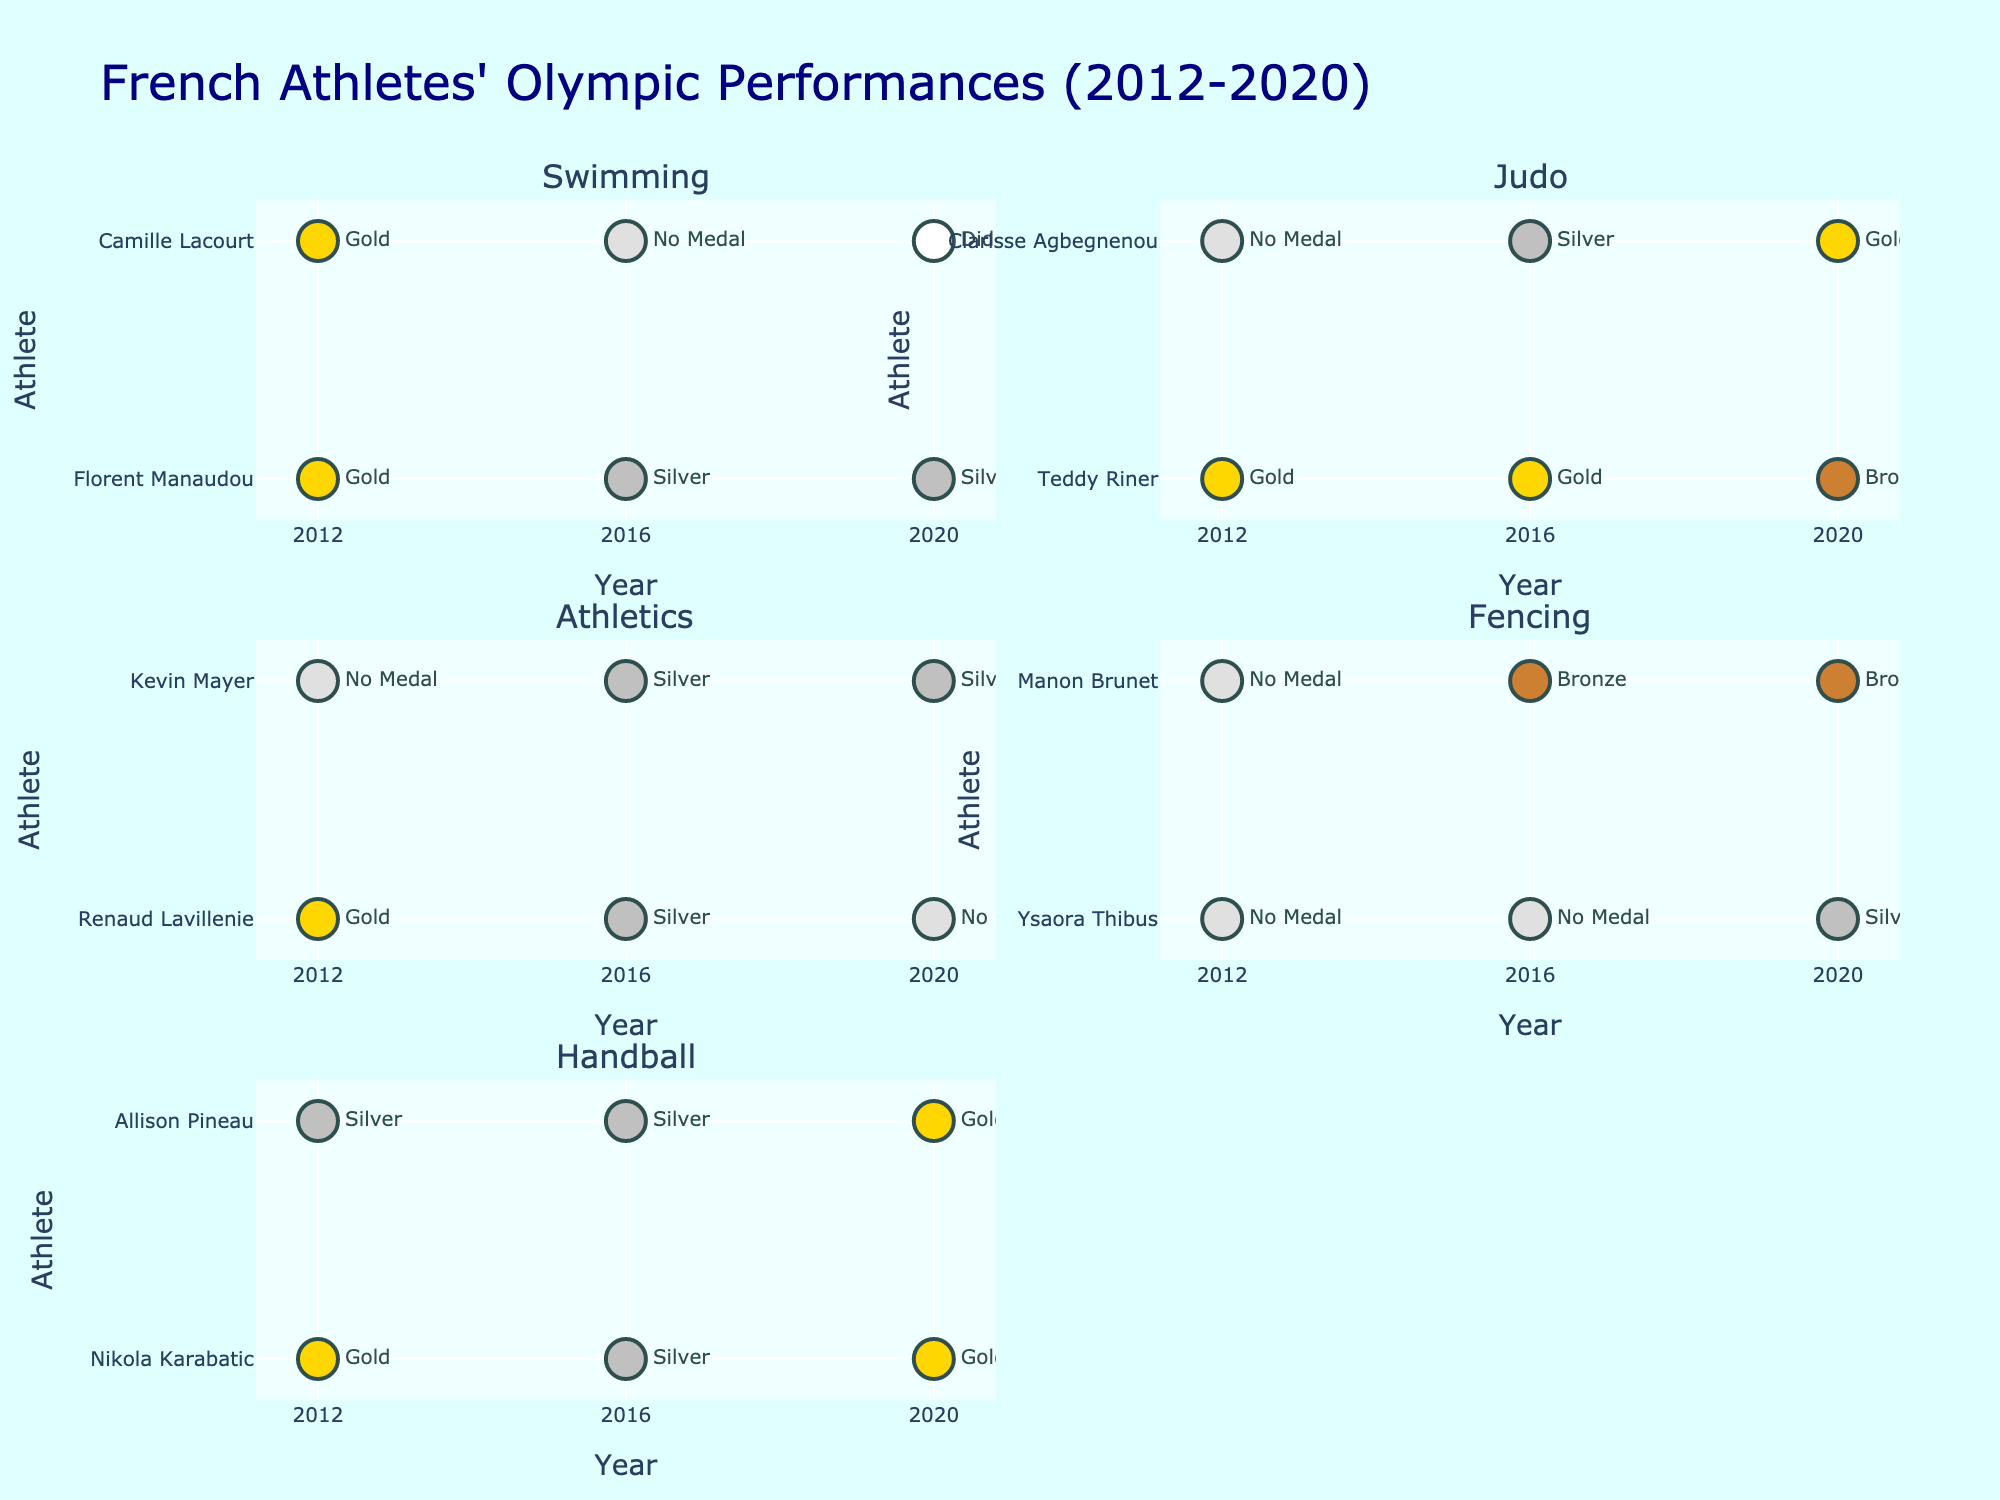What's the title of the figure? The title is usually located at the top of the figure. In this case, the title reads "Muscle Group Engagement in Various Sports."
Answer: Muscle Group Engagement in Various Sports Which muscle group engaged the most during Archery? Look at the Archery row and identify the highest bar in one of the subplots. In this case, the Forearms subplot shows the highest engagement at 90%.
Answer: Forearms How does the engagement of the Core muscles in Swimming compare to that in Tennis? Locate the "Core" subplot, then compare the bars for Swimming and Tennis. Swimming shows 75% engagement while Tennis shows 70%.
Answer: Swimming has 5% more engagement Which sport has the highest engagement of the Back muscles? Look at the Back subplot and identify the highest bar. Weightlifting shows the highest engagement at 85%.
Answer: Weightlifting What is the average engagement of Shoulders across all sports? Look at the Shoulders subplot and calculate the average: (80 + 85 + 65 + 80 + 75 + 85) / 6 = 78.33 rounded to 2 decimal places.
Answer: 78.33 In which sport is the engagement of Biceps equal to the engagement of Triceps? Look at both Biceps and Triceps subplots and identify if any sport has equal values. Tennis shows both at 75%.
Answer: Tennis Is the engagement of the Core muscles generally higher in Swimming or Basketball? Compare the Core engagement bars in the Swimming and Basketball subplots. Swimming shows 75% while Basketball shows 65%.
Answer: Swimming Which muscle group shows the least engagement in Basketball? Look at the Basketball row and identify the lowest bar in one of the subplots. The Forearms subplot shows the least engagement at 55%.
Answer: Forearms What's the difference in Back muscle engagement between Archery and Rock Climbing? Locate the Back subplot and find the difference between Archery (75%) and Rock Climbing (85%): 85% - 75% = 10%.
Answer: 10% Between Archery and Weightlifting, which engages the Biceps more and by how much? Compare the Biceps engagement bars for Archery and Weightlifting. Archery shows 85%, Weightlifting shows 90%. The difference is 90% - 85% = 5%.
Answer: Weightlifting by 5% 